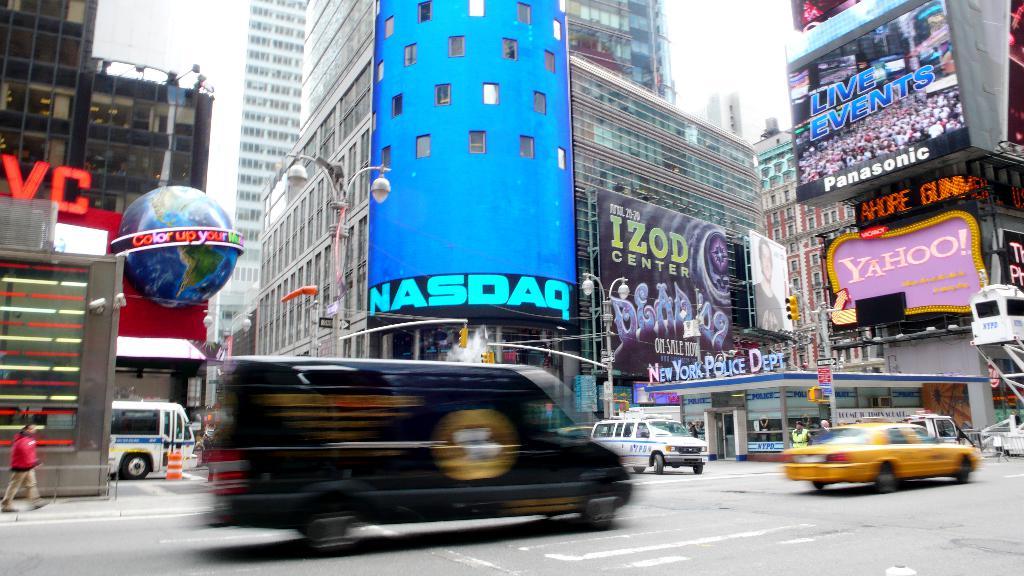What is on the purple sign?
Your answer should be very brief. Yahoo. 